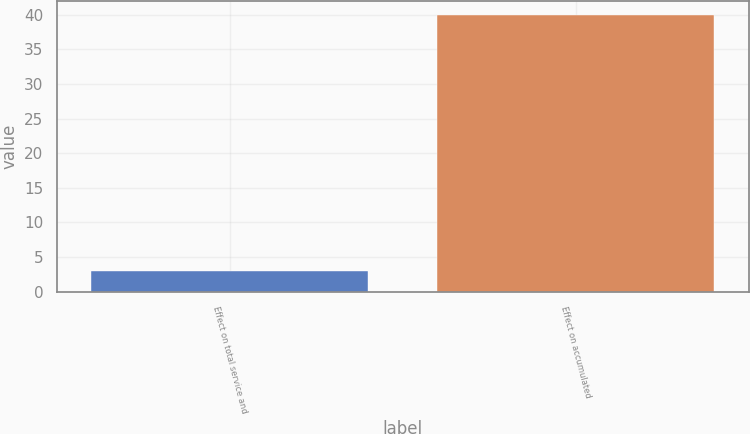Convert chart. <chart><loc_0><loc_0><loc_500><loc_500><bar_chart><fcel>Effect on total service and<fcel>Effect on accumulated<nl><fcel>3<fcel>40<nl></chart> 